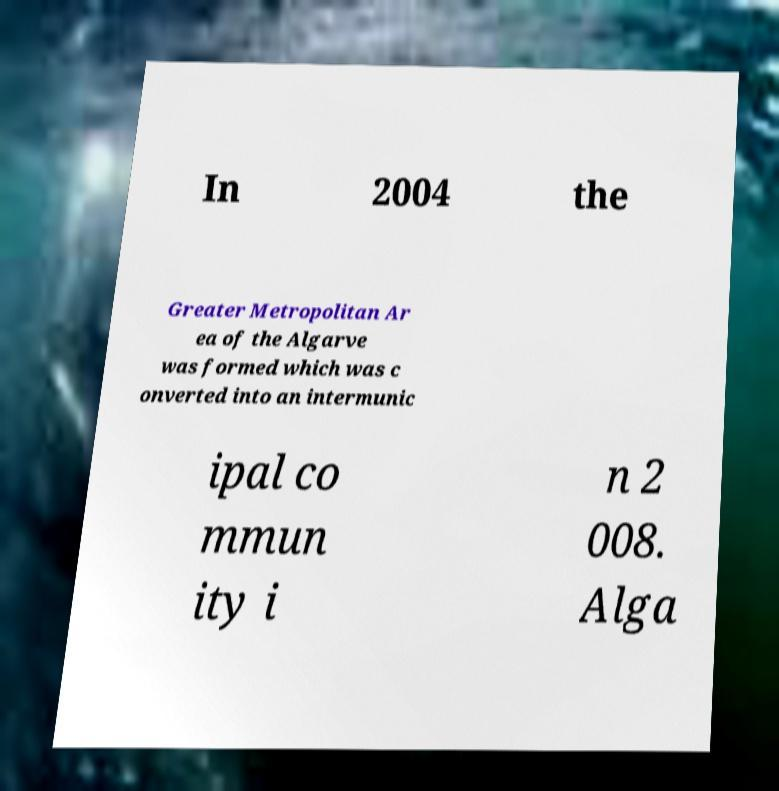For documentation purposes, I need the text within this image transcribed. Could you provide that? In 2004 the Greater Metropolitan Ar ea of the Algarve was formed which was c onverted into an intermunic ipal co mmun ity i n 2 008. Alga 